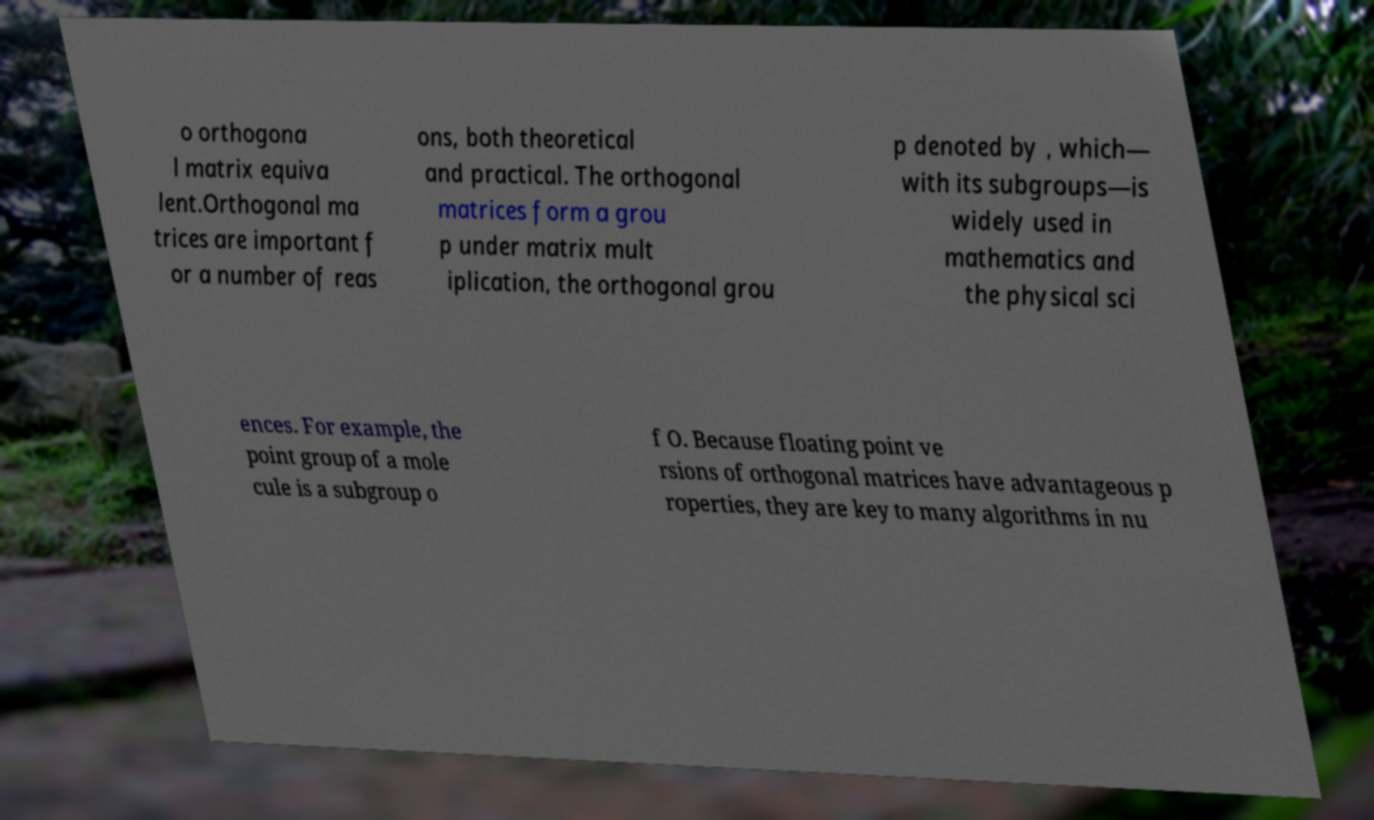Could you extract and type out the text from this image? o orthogona l matrix equiva lent.Orthogonal ma trices are important f or a number of reas ons, both theoretical and practical. The orthogonal matrices form a grou p under matrix mult iplication, the orthogonal grou p denoted by , which— with its subgroups—is widely used in mathematics and the physical sci ences. For example, the point group of a mole cule is a subgroup o f O. Because floating point ve rsions of orthogonal matrices have advantageous p roperties, they are key to many algorithms in nu 